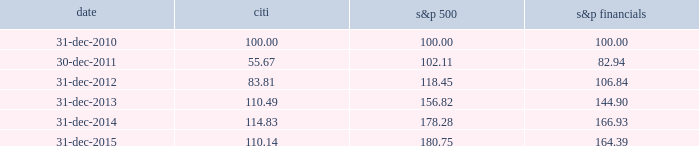Performance graph comparison of five-year cumulative total return the following graph and table compare the cumulative total return on citi 2019s common stock , which is listed on the nyse under the ticker symbol 201cc 201d and held by 81805 common stockholders of record as of january 31 , 2016 , with the cumulative total return of the s&p 500 index and the s&p financial index over the five-year period through december 31 , 2015 .
The graph and table assume that $ 100 was invested on december 31 , 2010 in citi 2019s common stock , the s&p 500 index and the s&p financial index , and that all dividends were reinvested .
Comparison of five-year cumulative total return for the years ended date citi s&p 500 financials .

What was the percentage cumulative total return of citi common stock for the five years ended 31-dec-2015? 
Computations: ((110.14 - 100) / 100)
Answer: 0.1014. 